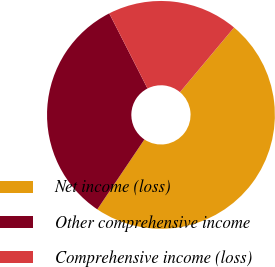Convert chart to OTSL. <chart><loc_0><loc_0><loc_500><loc_500><pie_chart><fcel>Net income (loss)<fcel>Other comprehensive income<fcel>Comprehensive income (loss)<nl><fcel>48.35%<fcel>33.07%<fcel>18.59%<nl></chart> 